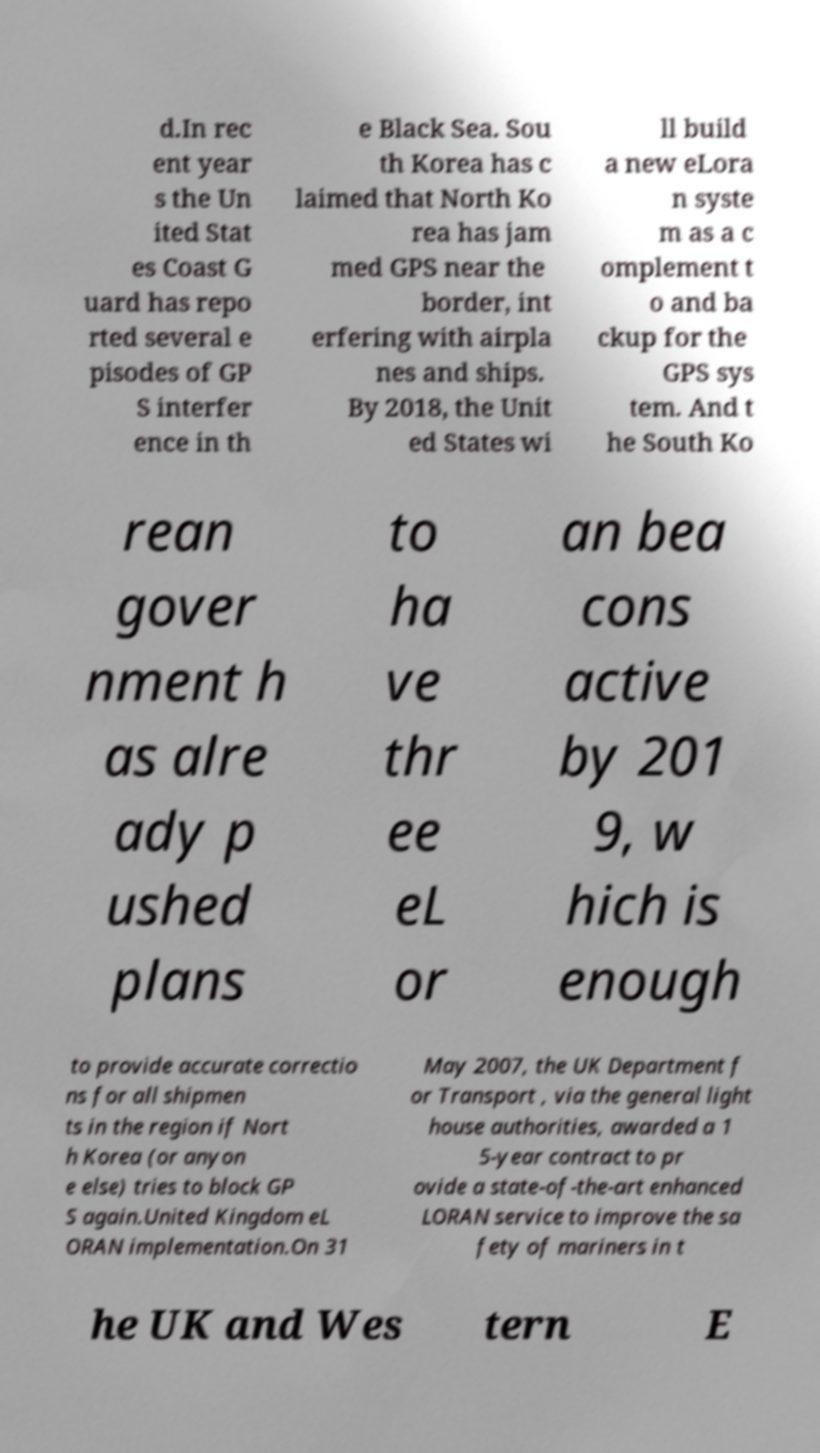Please read and relay the text visible in this image. What does it say? d.In rec ent year s the Un ited Stat es Coast G uard has repo rted several e pisodes of GP S interfer ence in th e Black Sea. Sou th Korea has c laimed that North Ko rea has jam med GPS near the border, int erfering with airpla nes and ships. By 2018, the Unit ed States wi ll build a new eLora n syste m as a c omplement t o and ba ckup for the GPS sys tem. And t he South Ko rean gover nment h as alre ady p ushed plans to ha ve thr ee eL or an bea cons active by 201 9, w hich is enough to provide accurate correctio ns for all shipmen ts in the region if Nort h Korea (or anyon e else) tries to block GP S again.United Kingdom eL ORAN implementation.On 31 May 2007, the UK Department f or Transport , via the general light house authorities, awarded a 1 5-year contract to pr ovide a state-of-the-art enhanced LORAN service to improve the sa fety of mariners in t he UK and Wes tern E 